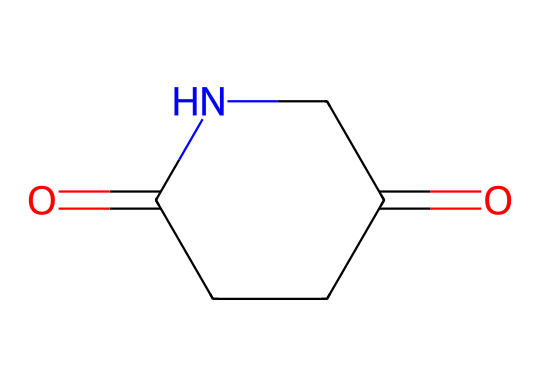What is the chemical name of the compound represented by this SMILES? The SMILES notation describes the structure of glutarimide, where the specific arrangement of atoms and functional groups leads to its naming.
Answer: glutarimide How many carbon atoms are present in this chemical? Analyzing the SMILES, we note there are five carbon atoms indicated by the "C" characters in the structure.
Answer: five What functional groups are present in glutarimide? Looking at the chemical structure, it contains both a carbonyl group (C=O) and an amide group (N-C). These together characterize the functional groups present.
Answer: carbonyl and amide What type of imide is glutarimide? Glutarimide is specifically characterized as a five-membered cyclic imide based on its ring structure and the presence of the nitrogen and carbonyls.
Answer: cyclic How many nitrogen atoms are in this structure? The SMILES notation shows only one nitrogen atom represented in the structure, confirming its presence.
Answer: one What property of glutarimide might indicate its use in antidepressants? The presence of amide functional groups often correlates with the ability of compounds to interact with neurotransmitter receptors in the brain, supporting its use in medications.
Answer: neurotransmitter interaction Can glutarimide form hydrogen bonds? Yes, the presence of the nitrogen atom in the amide group allows for hydrogen bonding with other molecules, a key feature for solubility and interaction in biological systems.
Answer: yes 